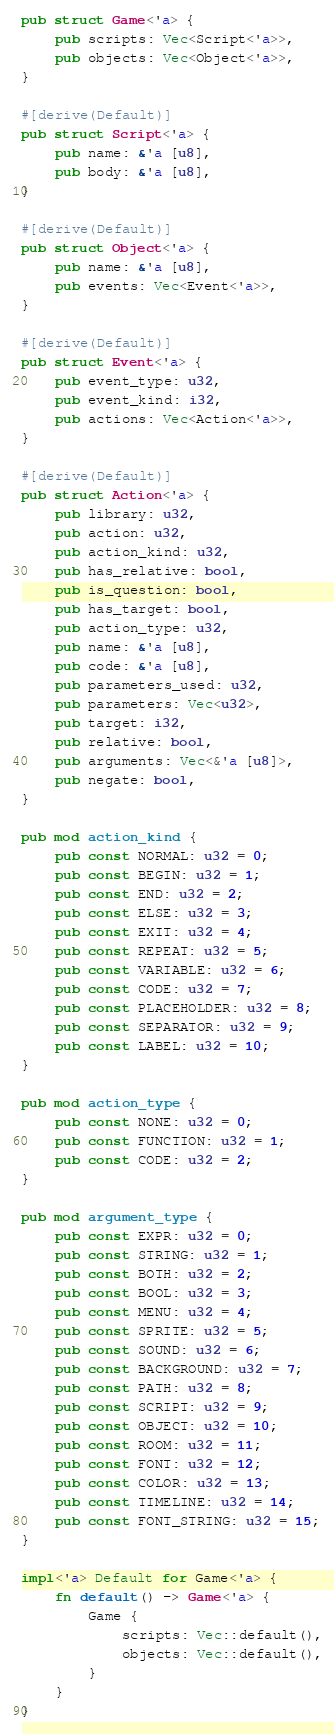<code> <loc_0><loc_0><loc_500><loc_500><_Rust_>pub struct Game<'a> {
    pub scripts: Vec<Script<'a>>,
    pub objects: Vec<Object<'a>>,
}

#[derive(Default)]
pub struct Script<'a> {
    pub name: &'a [u8],
    pub body: &'a [u8],
}

#[derive(Default)]
pub struct Object<'a> {
    pub name: &'a [u8],
    pub events: Vec<Event<'a>>,
}

#[derive(Default)]
pub struct Event<'a> {
    pub event_type: u32,
    pub event_kind: i32,
    pub actions: Vec<Action<'a>>,
}

#[derive(Default)]
pub struct Action<'a> {
    pub library: u32,
    pub action: u32,
    pub action_kind: u32,
    pub has_relative: bool,
    pub is_question: bool,
    pub has_target: bool,
    pub action_type: u32,
    pub name: &'a [u8],
    pub code: &'a [u8],
    pub parameters_used: u32,
    pub parameters: Vec<u32>,
    pub target: i32,
    pub relative: bool,
    pub arguments: Vec<&'a [u8]>,
    pub negate: bool,
}

pub mod action_kind {
    pub const NORMAL: u32 = 0;
    pub const BEGIN: u32 = 1;
    pub const END: u32 = 2;
    pub const ELSE: u32 = 3;
    pub const EXIT: u32 = 4;
    pub const REPEAT: u32 = 5;
    pub const VARIABLE: u32 = 6;
    pub const CODE: u32 = 7;
    pub const PLACEHOLDER: u32 = 8;
    pub const SEPARATOR: u32 = 9;
    pub const LABEL: u32 = 10;
}

pub mod action_type {
    pub const NONE: u32 = 0;
    pub const FUNCTION: u32 = 1;
    pub const CODE: u32 = 2;
}

pub mod argument_type {
    pub const EXPR: u32 = 0;
    pub const STRING: u32 = 1;
    pub const BOTH: u32 = 2;
    pub const BOOL: u32 = 3;
    pub const MENU: u32 = 4;
    pub const SPRITE: u32 = 5;
    pub const SOUND: u32 = 6;
    pub const BACKGROUND: u32 = 7;
    pub const PATH: u32 = 8;
    pub const SCRIPT: u32 = 9;
    pub const OBJECT: u32 = 10;
    pub const ROOM: u32 = 11;
    pub const FONT: u32 = 12;
    pub const COLOR: u32 = 13;
    pub const TIMELINE: u32 = 14;
    pub const FONT_STRING: u32 = 15;
}

impl<'a> Default for Game<'a> {
    fn default() -> Game<'a> {
        Game {
            scripts: Vec::default(),
            objects: Vec::default(),
        }
    }
}
</code> 